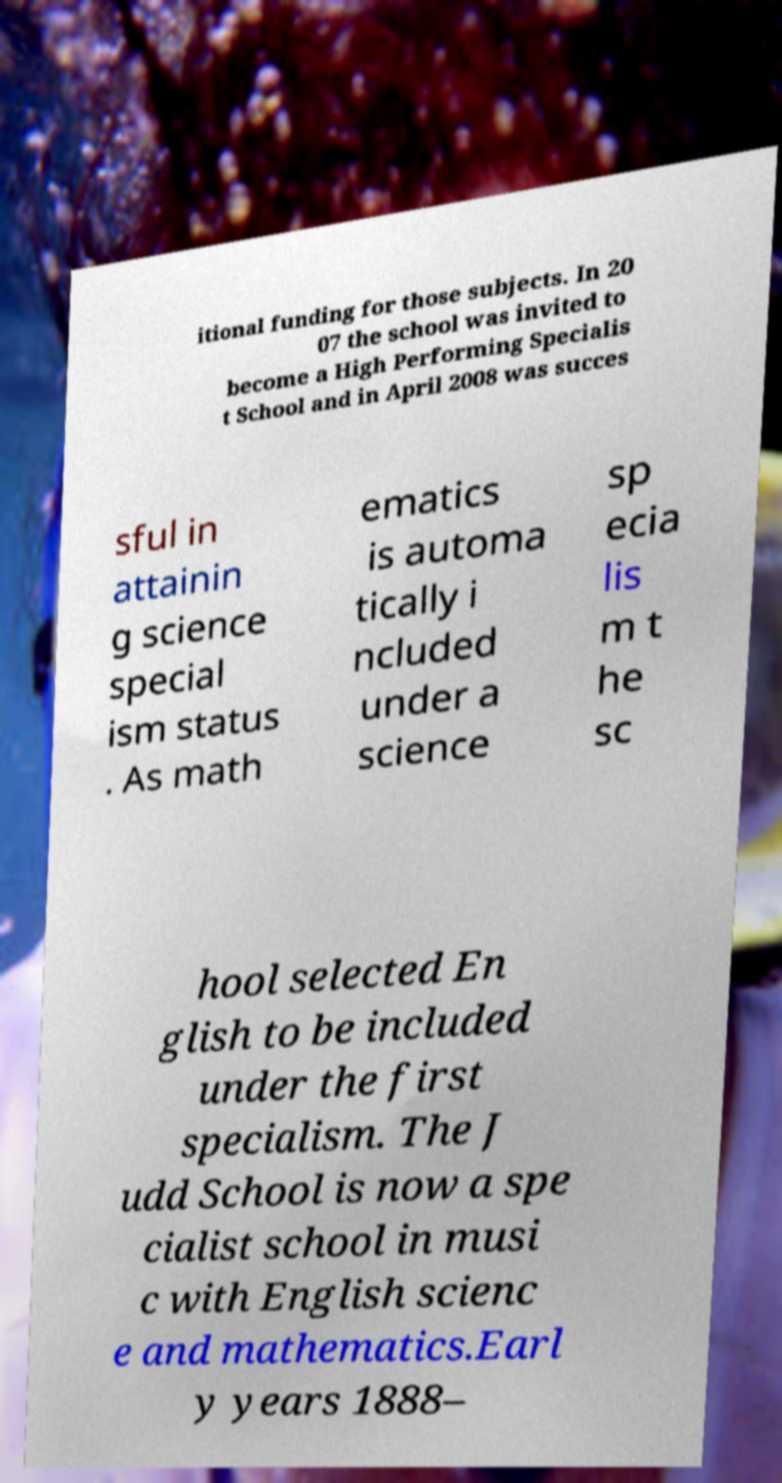There's text embedded in this image that I need extracted. Can you transcribe it verbatim? itional funding for those subjects. In 20 07 the school was invited to become a High Performing Specialis t School and in April 2008 was succes sful in attainin g science special ism status . As math ematics is automa tically i ncluded under a science sp ecia lis m t he sc hool selected En glish to be included under the first specialism. The J udd School is now a spe cialist school in musi c with English scienc e and mathematics.Earl y years 1888– 